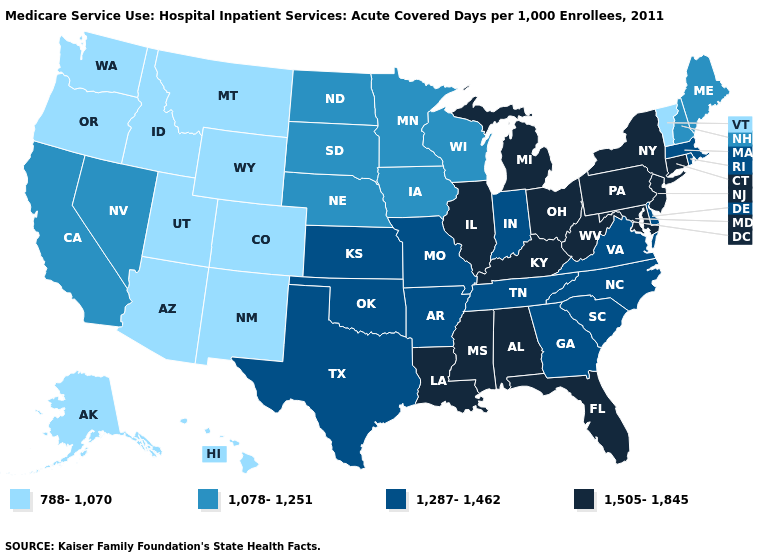What is the value of Wisconsin?
Quick response, please. 1,078-1,251. Name the states that have a value in the range 1,505-1,845?
Concise answer only. Alabama, Connecticut, Florida, Illinois, Kentucky, Louisiana, Maryland, Michigan, Mississippi, New Jersey, New York, Ohio, Pennsylvania, West Virginia. Does the map have missing data?
Short answer required. No. Is the legend a continuous bar?
Quick response, please. No. Name the states that have a value in the range 1,078-1,251?
Write a very short answer. California, Iowa, Maine, Minnesota, Nebraska, Nevada, New Hampshire, North Dakota, South Dakota, Wisconsin. Name the states that have a value in the range 1,078-1,251?
Answer briefly. California, Iowa, Maine, Minnesota, Nebraska, Nevada, New Hampshire, North Dakota, South Dakota, Wisconsin. What is the highest value in the MidWest ?
Answer briefly. 1,505-1,845. What is the highest value in the Northeast ?
Short answer required. 1,505-1,845. Does Florida have a higher value than North Carolina?
Write a very short answer. Yes. Which states have the highest value in the USA?
Be succinct. Alabama, Connecticut, Florida, Illinois, Kentucky, Louisiana, Maryland, Michigan, Mississippi, New Jersey, New York, Ohio, Pennsylvania, West Virginia. What is the value of Wyoming?
Short answer required. 788-1,070. What is the highest value in the USA?
Quick response, please. 1,505-1,845. Name the states that have a value in the range 1,505-1,845?
Short answer required. Alabama, Connecticut, Florida, Illinois, Kentucky, Louisiana, Maryland, Michigan, Mississippi, New Jersey, New York, Ohio, Pennsylvania, West Virginia. What is the lowest value in the USA?
Concise answer only. 788-1,070. What is the highest value in states that border Minnesota?
Short answer required. 1,078-1,251. 